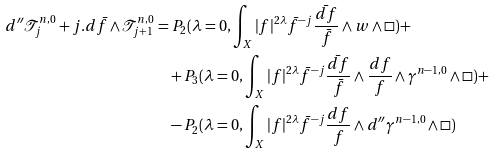<formula> <loc_0><loc_0><loc_500><loc_500>d ^ { \prime \prime } \mathcal { T } ^ { n , 0 } _ { j } + j . d \bar { f } \wedge \mathcal { T } ^ { n , 0 } _ { j + 1 } = & \ P _ { 2 } ( \lambda = 0 , \int _ { X } | f | ^ { 2 \lambda } \bar { f } ^ { - j } \frac { \bar { d f } } { \bar { f } } \wedge w \wedge \Box ) + \\ & + P _ { 3 } ( \lambda = 0 , \int _ { X } | f | ^ { 2 \lambda } \bar { f } ^ { - j } \frac { \bar { d f } } { \bar { f } } \wedge \frac { d f } { f } \wedge \gamma ^ { n - 1 , 0 } \wedge \Box ) + \\ & - P _ { 2 } ( \lambda = 0 , \int _ { X } | f | ^ { 2 \lambda } \bar { f } ^ { - j } \frac { d f } { f } \wedge d ^ { \prime \prime } \gamma ^ { n - 1 , 0 } \wedge \Box )</formula> 